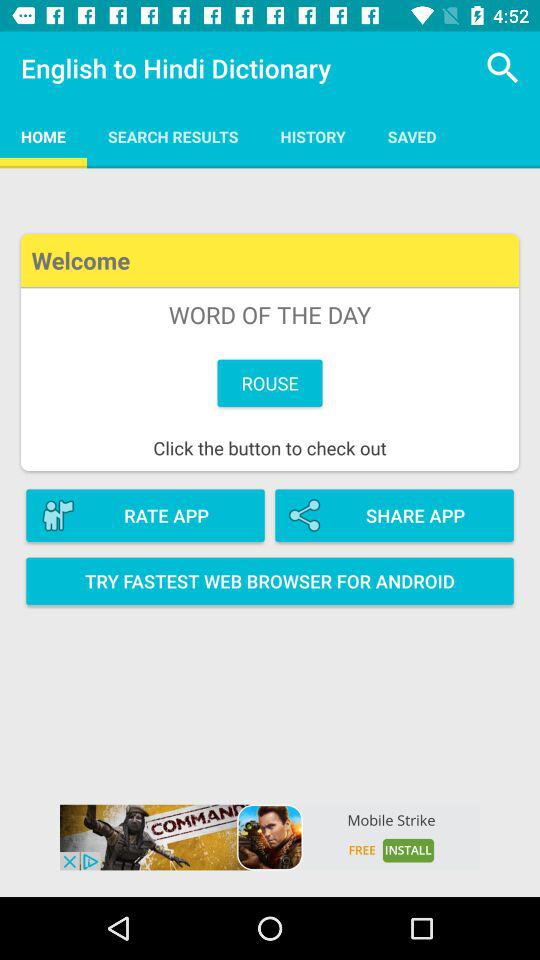Which tab am I on? You are on the "HOME" tab. 